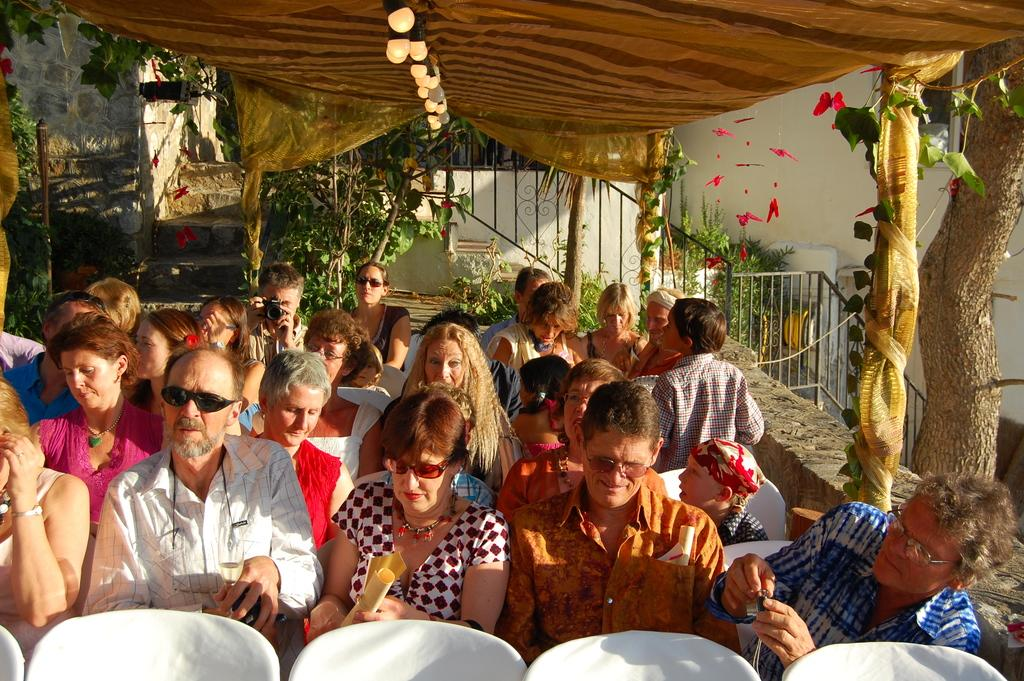What are the people in the image doing? The people in the image are sitting. What type of furniture can be seen at the bottom of the image? There are chairs at the bottom of the image. What can be seen in the background of the image? In the background of the image, there are trees, stairs, plants, lights, and a tent. What feature is present in the image that might provide safety or support? There is a railing in the image. How do the people in the image exchange their thoughts and ideas? There is no indication in the image that the people are exchanging thoughts or ideas. What type of grip do the trees in the background have? The trees in the background do not have a grip; they are stationary plants. 